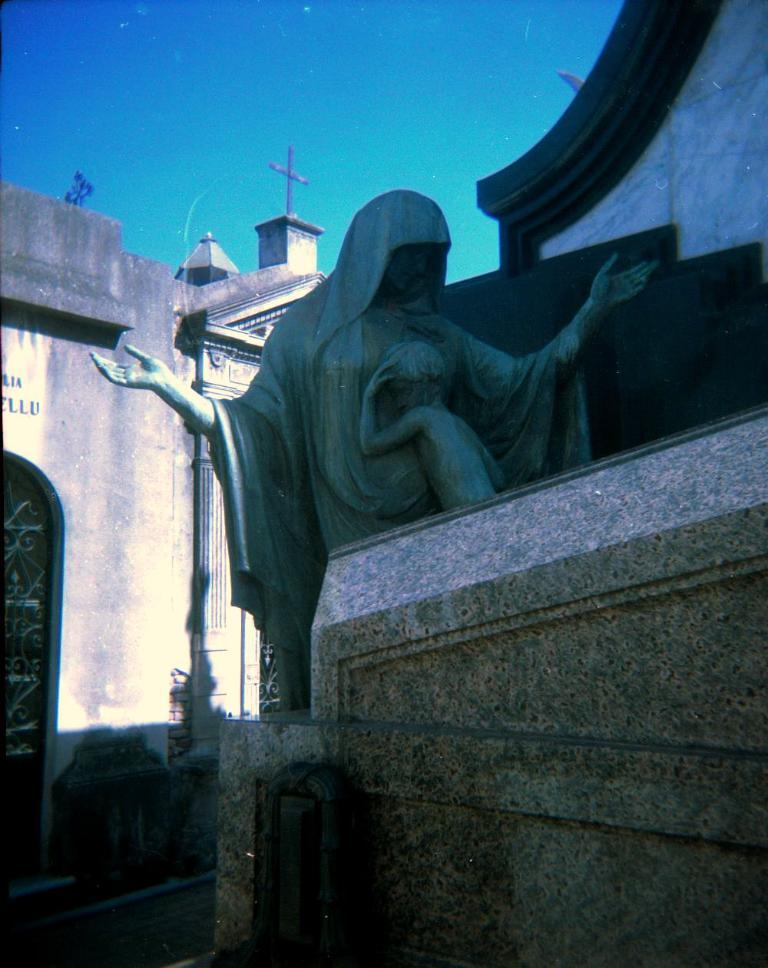What is the main subject in the image? There is a statue in the image. What can be seen on the left side of the image? There is a wall on the left side of the image. What symbol is present at the top of the image? There is a cross symbol on the top of the image. What is visible in the background of the image? The sky is visible in the background of the image. What type of jelly is being used to decorate the statue in the image? There is no jelly present in the image, and therefore no such decoration can be observed. 